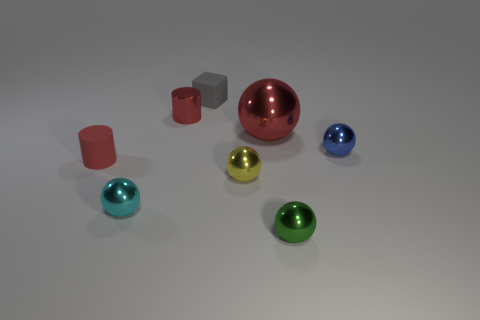Do the large red shiny object and the tiny green shiny object have the same shape?
Keep it short and to the point. Yes. How many things are small metal objects that are behind the green object or small cyan metal spheres?
Provide a succinct answer. 4. Is the number of tiny cubes in front of the tiny yellow object the same as the number of tiny matte objects behind the small red matte object?
Offer a very short reply. No. How many other objects are the same shape as the cyan object?
Offer a terse response. 4. Is the size of the red cylinder that is behind the tiny blue metal sphere the same as the rubber object in front of the gray matte object?
Offer a terse response. Yes. What number of blocks are large objects or small red metallic things?
Provide a succinct answer. 0. How many matte things are small spheres or green balls?
Give a very brief answer. 0. The red metal thing that is the same shape as the green shiny thing is what size?
Provide a succinct answer. Large. Are there any other things that have the same size as the blue sphere?
Your response must be concise. Yes. There is a green sphere; does it have the same size as the metal object on the right side of the tiny green thing?
Offer a very short reply. Yes. 